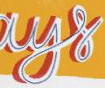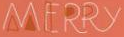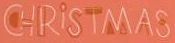What words can you see in these images in sequence, separated by a semicolon? ays; MERRY; CHRİSTMAS 